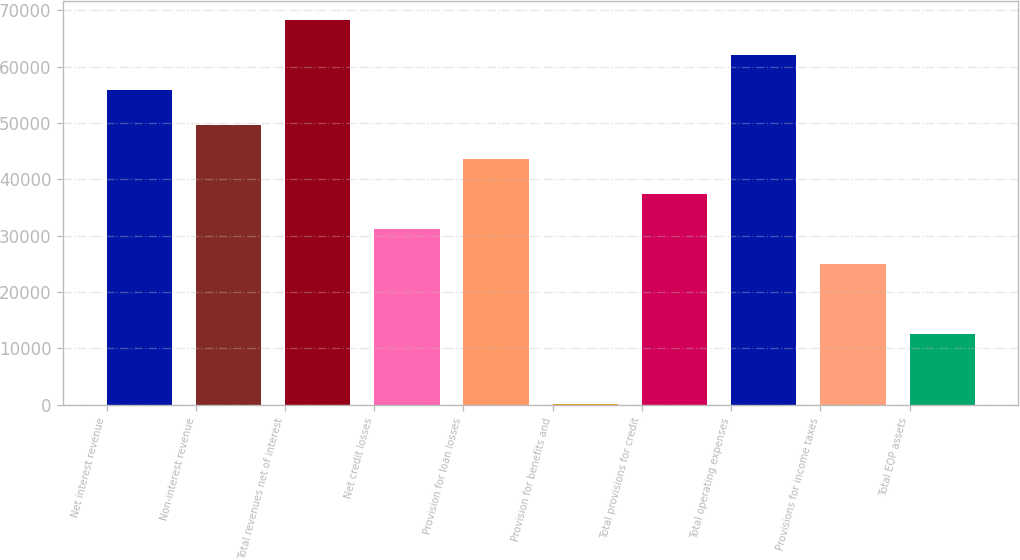Convert chart to OTSL. <chart><loc_0><loc_0><loc_500><loc_500><bar_chart><fcel>Net interest revenue<fcel>Non-interest revenue<fcel>Total revenues net of interest<fcel>Net credit losses<fcel>Provision for loan losses<fcel>Provision for benefits and<fcel>Total provisions for credit<fcel>Total operating expenses<fcel>Provisions for income taxes<fcel>Total EOP assets<nl><fcel>55903.1<fcel>49711.2<fcel>68286.9<fcel>31135.5<fcel>43519.3<fcel>176<fcel>37327.4<fcel>62095<fcel>24943.6<fcel>12559.8<nl></chart> 